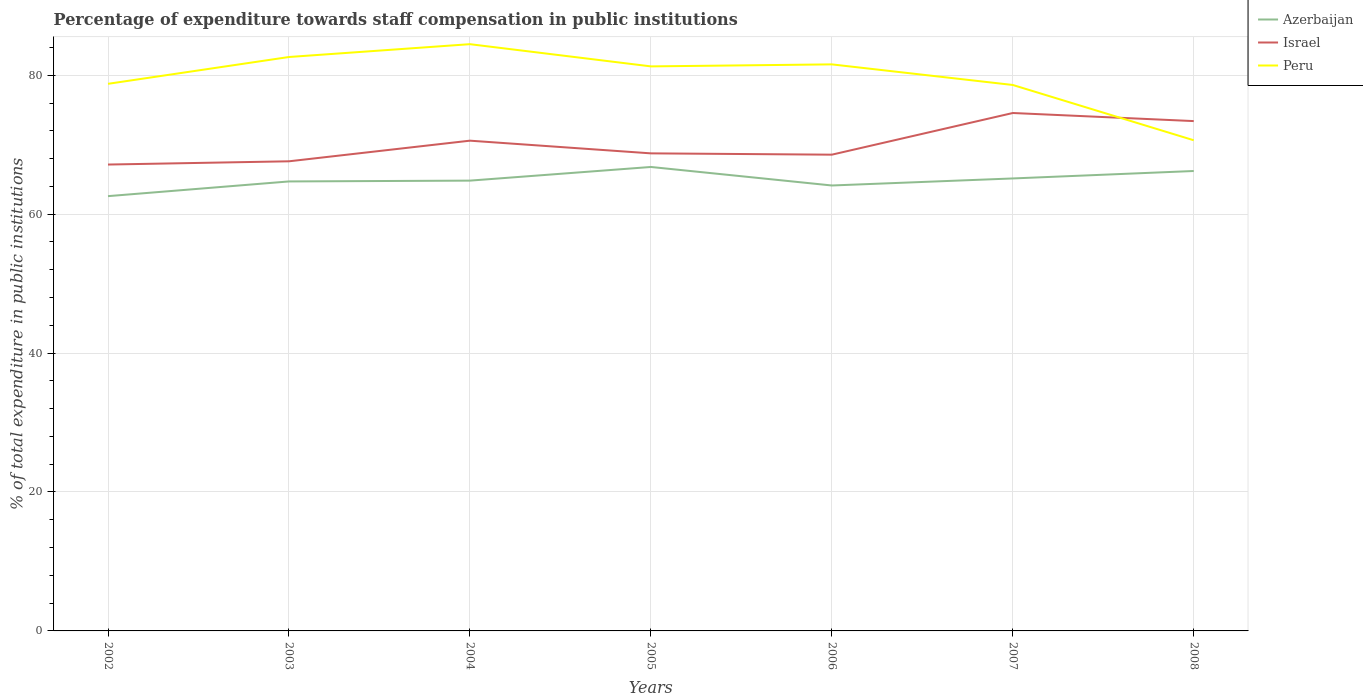How many different coloured lines are there?
Offer a terse response. 3. Is the number of lines equal to the number of legend labels?
Provide a short and direct response. Yes. Across all years, what is the maximum percentage of expenditure towards staff compensation in Peru?
Ensure brevity in your answer.  70.64. What is the total percentage of expenditure towards staff compensation in Israel in the graph?
Offer a very short reply. -3.44. What is the difference between the highest and the second highest percentage of expenditure towards staff compensation in Azerbaijan?
Your answer should be very brief. 4.2. What is the difference between the highest and the lowest percentage of expenditure towards staff compensation in Peru?
Your answer should be very brief. 4. Are the values on the major ticks of Y-axis written in scientific E-notation?
Give a very brief answer. No. Does the graph contain any zero values?
Your answer should be very brief. No. What is the title of the graph?
Provide a short and direct response. Percentage of expenditure towards staff compensation in public institutions. Does "Chad" appear as one of the legend labels in the graph?
Offer a very short reply. No. What is the label or title of the X-axis?
Your answer should be very brief. Years. What is the label or title of the Y-axis?
Ensure brevity in your answer.  % of total expenditure in public institutions. What is the % of total expenditure in public institutions in Azerbaijan in 2002?
Offer a terse response. 62.59. What is the % of total expenditure in public institutions of Israel in 2002?
Offer a very short reply. 67.14. What is the % of total expenditure in public institutions in Peru in 2002?
Your answer should be compact. 78.76. What is the % of total expenditure in public institutions in Azerbaijan in 2003?
Make the answer very short. 64.71. What is the % of total expenditure in public institutions in Israel in 2003?
Provide a short and direct response. 67.61. What is the % of total expenditure in public institutions in Peru in 2003?
Give a very brief answer. 82.62. What is the % of total expenditure in public institutions of Azerbaijan in 2004?
Give a very brief answer. 64.83. What is the % of total expenditure in public institutions of Israel in 2004?
Offer a very short reply. 70.58. What is the % of total expenditure in public institutions in Peru in 2004?
Ensure brevity in your answer.  84.47. What is the % of total expenditure in public institutions of Azerbaijan in 2005?
Give a very brief answer. 66.79. What is the % of total expenditure in public institutions of Israel in 2005?
Make the answer very short. 68.75. What is the % of total expenditure in public institutions in Peru in 2005?
Provide a succinct answer. 81.27. What is the % of total expenditure in public institutions in Azerbaijan in 2006?
Your response must be concise. 64.13. What is the % of total expenditure in public institutions in Israel in 2006?
Provide a short and direct response. 68.56. What is the % of total expenditure in public institutions in Peru in 2006?
Offer a very short reply. 81.56. What is the % of total expenditure in public institutions in Azerbaijan in 2007?
Your answer should be compact. 65.14. What is the % of total expenditure in public institutions of Israel in 2007?
Ensure brevity in your answer.  74.56. What is the % of total expenditure in public institutions of Peru in 2007?
Provide a short and direct response. 78.6. What is the % of total expenditure in public institutions in Azerbaijan in 2008?
Your answer should be very brief. 66.21. What is the % of total expenditure in public institutions of Israel in 2008?
Provide a short and direct response. 73.4. What is the % of total expenditure in public institutions of Peru in 2008?
Offer a terse response. 70.64. Across all years, what is the maximum % of total expenditure in public institutions of Azerbaijan?
Your response must be concise. 66.79. Across all years, what is the maximum % of total expenditure in public institutions in Israel?
Provide a short and direct response. 74.56. Across all years, what is the maximum % of total expenditure in public institutions of Peru?
Keep it short and to the point. 84.47. Across all years, what is the minimum % of total expenditure in public institutions in Azerbaijan?
Your answer should be compact. 62.59. Across all years, what is the minimum % of total expenditure in public institutions of Israel?
Provide a short and direct response. 67.14. Across all years, what is the minimum % of total expenditure in public institutions of Peru?
Provide a short and direct response. 70.64. What is the total % of total expenditure in public institutions in Azerbaijan in the graph?
Your answer should be very brief. 454.39. What is the total % of total expenditure in public institutions of Israel in the graph?
Your response must be concise. 490.59. What is the total % of total expenditure in public institutions of Peru in the graph?
Give a very brief answer. 557.92. What is the difference between the % of total expenditure in public institutions in Azerbaijan in 2002 and that in 2003?
Your answer should be very brief. -2.12. What is the difference between the % of total expenditure in public institutions of Israel in 2002 and that in 2003?
Give a very brief answer. -0.47. What is the difference between the % of total expenditure in public institutions of Peru in 2002 and that in 2003?
Give a very brief answer. -3.86. What is the difference between the % of total expenditure in public institutions of Azerbaijan in 2002 and that in 2004?
Give a very brief answer. -2.23. What is the difference between the % of total expenditure in public institutions of Israel in 2002 and that in 2004?
Make the answer very short. -3.44. What is the difference between the % of total expenditure in public institutions of Peru in 2002 and that in 2004?
Make the answer very short. -5.71. What is the difference between the % of total expenditure in public institutions of Azerbaijan in 2002 and that in 2005?
Your response must be concise. -4.2. What is the difference between the % of total expenditure in public institutions of Israel in 2002 and that in 2005?
Keep it short and to the point. -1.61. What is the difference between the % of total expenditure in public institutions of Peru in 2002 and that in 2005?
Offer a very short reply. -2.51. What is the difference between the % of total expenditure in public institutions of Azerbaijan in 2002 and that in 2006?
Provide a succinct answer. -1.53. What is the difference between the % of total expenditure in public institutions in Israel in 2002 and that in 2006?
Make the answer very short. -1.42. What is the difference between the % of total expenditure in public institutions of Peru in 2002 and that in 2006?
Provide a short and direct response. -2.8. What is the difference between the % of total expenditure in public institutions of Azerbaijan in 2002 and that in 2007?
Provide a short and direct response. -2.55. What is the difference between the % of total expenditure in public institutions of Israel in 2002 and that in 2007?
Your response must be concise. -7.42. What is the difference between the % of total expenditure in public institutions in Peru in 2002 and that in 2007?
Your response must be concise. 0.17. What is the difference between the % of total expenditure in public institutions of Azerbaijan in 2002 and that in 2008?
Make the answer very short. -3.62. What is the difference between the % of total expenditure in public institutions in Israel in 2002 and that in 2008?
Your answer should be compact. -6.26. What is the difference between the % of total expenditure in public institutions in Peru in 2002 and that in 2008?
Your response must be concise. 8.13. What is the difference between the % of total expenditure in public institutions of Azerbaijan in 2003 and that in 2004?
Keep it short and to the point. -0.12. What is the difference between the % of total expenditure in public institutions of Israel in 2003 and that in 2004?
Provide a succinct answer. -2.97. What is the difference between the % of total expenditure in public institutions in Peru in 2003 and that in 2004?
Your answer should be compact. -1.85. What is the difference between the % of total expenditure in public institutions of Azerbaijan in 2003 and that in 2005?
Keep it short and to the point. -2.08. What is the difference between the % of total expenditure in public institutions in Israel in 2003 and that in 2005?
Give a very brief answer. -1.14. What is the difference between the % of total expenditure in public institutions in Peru in 2003 and that in 2005?
Provide a succinct answer. 1.35. What is the difference between the % of total expenditure in public institutions in Azerbaijan in 2003 and that in 2006?
Provide a succinct answer. 0.58. What is the difference between the % of total expenditure in public institutions in Israel in 2003 and that in 2006?
Offer a terse response. -0.95. What is the difference between the % of total expenditure in public institutions in Peru in 2003 and that in 2006?
Your response must be concise. 1.06. What is the difference between the % of total expenditure in public institutions in Azerbaijan in 2003 and that in 2007?
Offer a very short reply. -0.43. What is the difference between the % of total expenditure in public institutions in Israel in 2003 and that in 2007?
Offer a very short reply. -6.95. What is the difference between the % of total expenditure in public institutions of Peru in 2003 and that in 2007?
Provide a succinct answer. 4.03. What is the difference between the % of total expenditure in public institutions in Azerbaijan in 2003 and that in 2008?
Your answer should be compact. -1.5. What is the difference between the % of total expenditure in public institutions in Israel in 2003 and that in 2008?
Your response must be concise. -5.79. What is the difference between the % of total expenditure in public institutions of Peru in 2003 and that in 2008?
Give a very brief answer. 11.99. What is the difference between the % of total expenditure in public institutions in Azerbaijan in 2004 and that in 2005?
Offer a very short reply. -1.97. What is the difference between the % of total expenditure in public institutions in Israel in 2004 and that in 2005?
Provide a short and direct response. 1.83. What is the difference between the % of total expenditure in public institutions in Peru in 2004 and that in 2005?
Keep it short and to the point. 3.2. What is the difference between the % of total expenditure in public institutions of Azerbaijan in 2004 and that in 2006?
Offer a terse response. 0.7. What is the difference between the % of total expenditure in public institutions of Israel in 2004 and that in 2006?
Ensure brevity in your answer.  2.02. What is the difference between the % of total expenditure in public institutions of Peru in 2004 and that in 2006?
Provide a short and direct response. 2.91. What is the difference between the % of total expenditure in public institutions of Azerbaijan in 2004 and that in 2007?
Your answer should be compact. -0.31. What is the difference between the % of total expenditure in public institutions in Israel in 2004 and that in 2007?
Ensure brevity in your answer.  -3.98. What is the difference between the % of total expenditure in public institutions in Peru in 2004 and that in 2007?
Give a very brief answer. 5.87. What is the difference between the % of total expenditure in public institutions in Azerbaijan in 2004 and that in 2008?
Ensure brevity in your answer.  -1.39. What is the difference between the % of total expenditure in public institutions of Israel in 2004 and that in 2008?
Make the answer very short. -2.82. What is the difference between the % of total expenditure in public institutions of Peru in 2004 and that in 2008?
Provide a succinct answer. 13.83. What is the difference between the % of total expenditure in public institutions in Azerbaijan in 2005 and that in 2006?
Provide a short and direct response. 2.67. What is the difference between the % of total expenditure in public institutions of Israel in 2005 and that in 2006?
Your response must be concise. 0.19. What is the difference between the % of total expenditure in public institutions of Peru in 2005 and that in 2006?
Keep it short and to the point. -0.29. What is the difference between the % of total expenditure in public institutions of Azerbaijan in 2005 and that in 2007?
Offer a terse response. 1.65. What is the difference between the % of total expenditure in public institutions of Israel in 2005 and that in 2007?
Offer a very short reply. -5.81. What is the difference between the % of total expenditure in public institutions in Peru in 2005 and that in 2007?
Offer a very short reply. 2.68. What is the difference between the % of total expenditure in public institutions of Azerbaijan in 2005 and that in 2008?
Ensure brevity in your answer.  0.58. What is the difference between the % of total expenditure in public institutions of Israel in 2005 and that in 2008?
Offer a very short reply. -4.65. What is the difference between the % of total expenditure in public institutions in Peru in 2005 and that in 2008?
Provide a succinct answer. 10.64. What is the difference between the % of total expenditure in public institutions of Azerbaijan in 2006 and that in 2007?
Offer a very short reply. -1.01. What is the difference between the % of total expenditure in public institutions of Israel in 2006 and that in 2007?
Your answer should be compact. -6. What is the difference between the % of total expenditure in public institutions of Peru in 2006 and that in 2007?
Offer a very short reply. 2.97. What is the difference between the % of total expenditure in public institutions of Azerbaijan in 2006 and that in 2008?
Provide a succinct answer. -2.09. What is the difference between the % of total expenditure in public institutions in Israel in 2006 and that in 2008?
Provide a succinct answer. -4.83. What is the difference between the % of total expenditure in public institutions of Peru in 2006 and that in 2008?
Offer a terse response. 10.92. What is the difference between the % of total expenditure in public institutions in Azerbaijan in 2007 and that in 2008?
Offer a very short reply. -1.07. What is the difference between the % of total expenditure in public institutions in Israel in 2007 and that in 2008?
Keep it short and to the point. 1.16. What is the difference between the % of total expenditure in public institutions of Peru in 2007 and that in 2008?
Provide a succinct answer. 7.96. What is the difference between the % of total expenditure in public institutions in Azerbaijan in 2002 and the % of total expenditure in public institutions in Israel in 2003?
Provide a succinct answer. -5.01. What is the difference between the % of total expenditure in public institutions in Azerbaijan in 2002 and the % of total expenditure in public institutions in Peru in 2003?
Give a very brief answer. -20.03. What is the difference between the % of total expenditure in public institutions of Israel in 2002 and the % of total expenditure in public institutions of Peru in 2003?
Provide a succinct answer. -15.48. What is the difference between the % of total expenditure in public institutions of Azerbaijan in 2002 and the % of total expenditure in public institutions of Israel in 2004?
Offer a terse response. -7.99. What is the difference between the % of total expenditure in public institutions in Azerbaijan in 2002 and the % of total expenditure in public institutions in Peru in 2004?
Ensure brevity in your answer.  -21.88. What is the difference between the % of total expenditure in public institutions of Israel in 2002 and the % of total expenditure in public institutions of Peru in 2004?
Your response must be concise. -17.33. What is the difference between the % of total expenditure in public institutions of Azerbaijan in 2002 and the % of total expenditure in public institutions of Israel in 2005?
Offer a very short reply. -6.16. What is the difference between the % of total expenditure in public institutions in Azerbaijan in 2002 and the % of total expenditure in public institutions in Peru in 2005?
Provide a short and direct response. -18.68. What is the difference between the % of total expenditure in public institutions in Israel in 2002 and the % of total expenditure in public institutions in Peru in 2005?
Keep it short and to the point. -14.13. What is the difference between the % of total expenditure in public institutions in Azerbaijan in 2002 and the % of total expenditure in public institutions in Israel in 2006?
Ensure brevity in your answer.  -5.97. What is the difference between the % of total expenditure in public institutions in Azerbaijan in 2002 and the % of total expenditure in public institutions in Peru in 2006?
Provide a short and direct response. -18.97. What is the difference between the % of total expenditure in public institutions of Israel in 2002 and the % of total expenditure in public institutions of Peru in 2006?
Keep it short and to the point. -14.42. What is the difference between the % of total expenditure in public institutions of Azerbaijan in 2002 and the % of total expenditure in public institutions of Israel in 2007?
Provide a succinct answer. -11.97. What is the difference between the % of total expenditure in public institutions of Azerbaijan in 2002 and the % of total expenditure in public institutions of Peru in 2007?
Your answer should be very brief. -16. What is the difference between the % of total expenditure in public institutions in Israel in 2002 and the % of total expenditure in public institutions in Peru in 2007?
Make the answer very short. -11.46. What is the difference between the % of total expenditure in public institutions in Azerbaijan in 2002 and the % of total expenditure in public institutions in Israel in 2008?
Give a very brief answer. -10.8. What is the difference between the % of total expenditure in public institutions in Azerbaijan in 2002 and the % of total expenditure in public institutions in Peru in 2008?
Your response must be concise. -8.04. What is the difference between the % of total expenditure in public institutions in Israel in 2002 and the % of total expenditure in public institutions in Peru in 2008?
Ensure brevity in your answer.  -3.5. What is the difference between the % of total expenditure in public institutions in Azerbaijan in 2003 and the % of total expenditure in public institutions in Israel in 2004?
Offer a terse response. -5.87. What is the difference between the % of total expenditure in public institutions of Azerbaijan in 2003 and the % of total expenditure in public institutions of Peru in 2004?
Provide a short and direct response. -19.76. What is the difference between the % of total expenditure in public institutions of Israel in 2003 and the % of total expenditure in public institutions of Peru in 2004?
Your answer should be very brief. -16.86. What is the difference between the % of total expenditure in public institutions of Azerbaijan in 2003 and the % of total expenditure in public institutions of Israel in 2005?
Offer a terse response. -4.04. What is the difference between the % of total expenditure in public institutions of Azerbaijan in 2003 and the % of total expenditure in public institutions of Peru in 2005?
Give a very brief answer. -16.56. What is the difference between the % of total expenditure in public institutions of Israel in 2003 and the % of total expenditure in public institutions of Peru in 2005?
Provide a short and direct response. -13.66. What is the difference between the % of total expenditure in public institutions of Azerbaijan in 2003 and the % of total expenditure in public institutions of Israel in 2006?
Your response must be concise. -3.85. What is the difference between the % of total expenditure in public institutions in Azerbaijan in 2003 and the % of total expenditure in public institutions in Peru in 2006?
Make the answer very short. -16.85. What is the difference between the % of total expenditure in public institutions of Israel in 2003 and the % of total expenditure in public institutions of Peru in 2006?
Offer a terse response. -13.95. What is the difference between the % of total expenditure in public institutions in Azerbaijan in 2003 and the % of total expenditure in public institutions in Israel in 2007?
Your answer should be very brief. -9.85. What is the difference between the % of total expenditure in public institutions in Azerbaijan in 2003 and the % of total expenditure in public institutions in Peru in 2007?
Your answer should be very brief. -13.89. What is the difference between the % of total expenditure in public institutions in Israel in 2003 and the % of total expenditure in public institutions in Peru in 2007?
Offer a very short reply. -10.99. What is the difference between the % of total expenditure in public institutions of Azerbaijan in 2003 and the % of total expenditure in public institutions of Israel in 2008?
Your answer should be compact. -8.69. What is the difference between the % of total expenditure in public institutions in Azerbaijan in 2003 and the % of total expenditure in public institutions in Peru in 2008?
Your response must be concise. -5.93. What is the difference between the % of total expenditure in public institutions in Israel in 2003 and the % of total expenditure in public institutions in Peru in 2008?
Make the answer very short. -3.03. What is the difference between the % of total expenditure in public institutions in Azerbaijan in 2004 and the % of total expenditure in public institutions in Israel in 2005?
Keep it short and to the point. -3.93. What is the difference between the % of total expenditure in public institutions in Azerbaijan in 2004 and the % of total expenditure in public institutions in Peru in 2005?
Keep it short and to the point. -16.45. What is the difference between the % of total expenditure in public institutions in Israel in 2004 and the % of total expenditure in public institutions in Peru in 2005?
Keep it short and to the point. -10.69. What is the difference between the % of total expenditure in public institutions of Azerbaijan in 2004 and the % of total expenditure in public institutions of Israel in 2006?
Provide a succinct answer. -3.74. What is the difference between the % of total expenditure in public institutions in Azerbaijan in 2004 and the % of total expenditure in public institutions in Peru in 2006?
Your answer should be very brief. -16.74. What is the difference between the % of total expenditure in public institutions in Israel in 2004 and the % of total expenditure in public institutions in Peru in 2006?
Your response must be concise. -10.98. What is the difference between the % of total expenditure in public institutions of Azerbaijan in 2004 and the % of total expenditure in public institutions of Israel in 2007?
Offer a very short reply. -9.74. What is the difference between the % of total expenditure in public institutions of Azerbaijan in 2004 and the % of total expenditure in public institutions of Peru in 2007?
Make the answer very short. -13.77. What is the difference between the % of total expenditure in public institutions of Israel in 2004 and the % of total expenditure in public institutions of Peru in 2007?
Your answer should be very brief. -8.02. What is the difference between the % of total expenditure in public institutions in Azerbaijan in 2004 and the % of total expenditure in public institutions in Israel in 2008?
Offer a very short reply. -8.57. What is the difference between the % of total expenditure in public institutions in Azerbaijan in 2004 and the % of total expenditure in public institutions in Peru in 2008?
Offer a very short reply. -5.81. What is the difference between the % of total expenditure in public institutions of Israel in 2004 and the % of total expenditure in public institutions of Peru in 2008?
Your response must be concise. -0.06. What is the difference between the % of total expenditure in public institutions of Azerbaijan in 2005 and the % of total expenditure in public institutions of Israel in 2006?
Provide a short and direct response. -1.77. What is the difference between the % of total expenditure in public institutions of Azerbaijan in 2005 and the % of total expenditure in public institutions of Peru in 2006?
Your response must be concise. -14.77. What is the difference between the % of total expenditure in public institutions in Israel in 2005 and the % of total expenditure in public institutions in Peru in 2006?
Make the answer very short. -12.81. What is the difference between the % of total expenditure in public institutions of Azerbaijan in 2005 and the % of total expenditure in public institutions of Israel in 2007?
Make the answer very short. -7.77. What is the difference between the % of total expenditure in public institutions in Azerbaijan in 2005 and the % of total expenditure in public institutions in Peru in 2007?
Offer a very short reply. -11.8. What is the difference between the % of total expenditure in public institutions of Israel in 2005 and the % of total expenditure in public institutions of Peru in 2007?
Keep it short and to the point. -9.84. What is the difference between the % of total expenditure in public institutions in Azerbaijan in 2005 and the % of total expenditure in public institutions in Israel in 2008?
Keep it short and to the point. -6.6. What is the difference between the % of total expenditure in public institutions in Azerbaijan in 2005 and the % of total expenditure in public institutions in Peru in 2008?
Give a very brief answer. -3.84. What is the difference between the % of total expenditure in public institutions of Israel in 2005 and the % of total expenditure in public institutions of Peru in 2008?
Offer a terse response. -1.89. What is the difference between the % of total expenditure in public institutions in Azerbaijan in 2006 and the % of total expenditure in public institutions in Israel in 2007?
Provide a short and direct response. -10.43. What is the difference between the % of total expenditure in public institutions in Azerbaijan in 2006 and the % of total expenditure in public institutions in Peru in 2007?
Provide a short and direct response. -14.47. What is the difference between the % of total expenditure in public institutions in Israel in 2006 and the % of total expenditure in public institutions in Peru in 2007?
Your response must be concise. -10.03. What is the difference between the % of total expenditure in public institutions in Azerbaijan in 2006 and the % of total expenditure in public institutions in Israel in 2008?
Provide a succinct answer. -9.27. What is the difference between the % of total expenditure in public institutions in Azerbaijan in 2006 and the % of total expenditure in public institutions in Peru in 2008?
Your response must be concise. -6.51. What is the difference between the % of total expenditure in public institutions of Israel in 2006 and the % of total expenditure in public institutions of Peru in 2008?
Give a very brief answer. -2.07. What is the difference between the % of total expenditure in public institutions in Azerbaijan in 2007 and the % of total expenditure in public institutions in Israel in 2008?
Make the answer very short. -8.26. What is the difference between the % of total expenditure in public institutions of Azerbaijan in 2007 and the % of total expenditure in public institutions of Peru in 2008?
Provide a short and direct response. -5.5. What is the difference between the % of total expenditure in public institutions in Israel in 2007 and the % of total expenditure in public institutions in Peru in 2008?
Keep it short and to the point. 3.92. What is the average % of total expenditure in public institutions in Azerbaijan per year?
Provide a succinct answer. 64.91. What is the average % of total expenditure in public institutions of Israel per year?
Your answer should be compact. 70.08. What is the average % of total expenditure in public institutions of Peru per year?
Your response must be concise. 79.7. In the year 2002, what is the difference between the % of total expenditure in public institutions of Azerbaijan and % of total expenditure in public institutions of Israel?
Your response must be concise. -4.55. In the year 2002, what is the difference between the % of total expenditure in public institutions in Azerbaijan and % of total expenditure in public institutions in Peru?
Your answer should be compact. -16.17. In the year 2002, what is the difference between the % of total expenditure in public institutions in Israel and % of total expenditure in public institutions in Peru?
Your response must be concise. -11.62. In the year 2003, what is the difference between the % of total expenditure in public institutions of Azerbaijan and % of total expenditure in public institutions of Israel?
Offer a very short reply. -2.9. In the year 2003, what is the difference between the % of total expenditure in public institutions of Azerbaijan and % of total expenditure in public institutions of Peru?
Make the answer very short. -17.91. In the year 2003, what is the difference between the % of total expenditure in public institutions in Israel and % of total expenditure in public institutions in Peru?
Your answer should be compact. -15.02. In the year 2004, what is the difference between the % of total expenditure in public institutions of Azerbaijan and % of total expenditure in public institutions of Israel?
Make the answer very short. -5.75. In the year 2004, what is the difference between the % of total expenditure in public institutions of Azerbaijan and % of total expenditure in public institutions of Peru?
Provide a succinct answer. -19.64. In the year 2004, what is the difference between the % of total expenditure in public institutions in Israel and % of total expenditure in public institutions in Peru?
Offer a very short reply. -13.89. In the year 2005, what is the difference between the % of total expenditure in public institutions of Azerbaijan and % of total expenditure in public institutions of Israel?
Provide a succinct answer. -1.96. In the year 2005, what is the difference between the % of total expenditure in public institutions in Azerbaijan and % of total expenditure in public institutions in Peru?
Make the answer very short. -14.48. In the year 2005, what is the difference between the % of total expenditure in public institutions of Israel and % of total expenditure in public institutions of Peru?
Provide a short and direct response. -12.52. In the year 2006, what is the difference between the % of total expenditure in public institutions in Azerbaijan and % of total expenditure in public institutions in Israel?
Ensure brevity in your answer.  -4.44. In the year 2006, what is the difference between the % of total expenditure in public institutions of Azerbaijan and % of total expenditure in public institutions of Peru?
Offer a terse response. -17.43. In the year 2006, what is the difference between the % of total expenditure in public institutions of Israel and % of total expenditure in public institutions of Peru?
Your answer should be very brief. -13. In the year 2007, what is the difference between the % of total expenditure in public institutions in Azerbaijan and % of total expenditure in public institutions in Israel?
Your response must be concise. -9.42. In the year 2007, what is the difference between the % of total expenditure in public institutions in Azerbaijan and % of total expenditure in public institutions in Peru?
Your answer should be very brief. -13.46. In the year 2007, what is the difference between the % of total expenditure in public institutions in Israel and % of total expenditure in public institutions in Peru?
Offer a terse response. -4.03. In the year 2008, what is the difference between the % of total expenditure in public institutions in Azerbaijan and % of total expenditure in public institutions in Israel?
Your answer should be compact. -7.18. In the year 2008, what is the difference between the % of total expenditure in public institutions of Azerbaijan and % of total expenditure in public institutions of Peru?
Ensure brevity in your answer.  -4.42. In the year 2008, what is the difference between the % of total expenditure in public institutions of Israel and % of total expenditure in public institutions of Peru?
Offer a terse response. 2.76. What is the ratio of the % of total expenditure in public institutions in Azerbaijan in 2002 to that in 2003?
Offer a terse response. 0.97. What is the ratio of the % of total expenditure in public institutions in Israel in 2002 to that in 2003?
Your answer should be very brief. 0.99. What is the ratio of the % of total expenditure in public institutions in Peru in 2002 to that in 2003?
Your response must be concise. 0.95. What is the ratio of the % of total expenditure in public institutions in Azerbaijan in 2002 to that in 2004?
Your answer should be very brief. 0.97. What is the ratio of the % of total expenditure in public institutions of Israel in 2002 to that in 2004?
Keep it short and to the point. 0.95. What is the ratio of the % of total expenditure in public institutions in Peru in 2002 to that in 2004?
Ensure brevity in your answer.  0.93. What is the ratio of the % of total expenditure in public institutions of Azerbaijan in 2002 to that in 2005?
Provide a succinct answer. 0.94. What is the ratio of the % of total expenditure in public institutions of Israel in 2002 to that in 2005?
Make the answer very short. 0.98. What is the ratio of the % of total expenditure in public institutions in Peru in 2002 to that in 2005?
Provide a succinct answer. 0.97. What is the ratio of the % of total expenditure in public institutions of Azerbaijan in 2002 to that in 2006?
Provide a succinct answer. 0.98. What is the ratio of the % of total expenditure in public institutions in Israel in 2002 to that in 2006?
Offer a very short reply. 0.98. What is the ratio of the % of total expenditure in public institutions in Peru in 2002 to that in 2006?
Make the answer very short. 0.97. What is the ratio of the % of total expenditure in public institutions of Azerbaijan in 2002 to that in 2007?
Provide a short and direct response. 0.96. What is the ratio of the % of total expenditure in public institutions in Israel in 2002 to that in 2007?
Make the answer very short. 0.9. What is the ratio of the % of total expenditure in public institutions in Azerbaijan in 2002 to that in 2008?
Offer a terse response. 0.95. What is the ratio of the % of total expenditure in public institutions of Israel in 2002 to that in 2008?
Keep it short and to the point. 0.91. What is the ratio of the % of total expenditure in public institutions of Peru in 2002 to that in 2008?
Your answer should be compact. 1.11. What is the ratio of the % of total expenditure in public institutions in Azerbaijan in 2003 to that in 2004?
Your response must be concise. 1. What is the ratio of the % of total expenditure in public institutions in Israel in 2003 to that in 2004?
Ensure brevity in your answer.  0.96. What is the ratio of the % of total expenditure in public institutions of Peru in 2003 to that in 2004?
Offer a terse response. 0.98. What is the ratio of the % of total expenditure in public institutions of Azerbaijan in 2003 to that in 2005?
Your answer should be very brief. 0.97. What is the ratio of the % of total expenditure in public institutions of Israel in 2003 to that in 2005?
Your response must be concise. 0.98. What is the ratio of the % of total expenditure in public institutions in Peru in 2003 to that in 2005?
Provide a short and direct response. 1.02. What is the ratio of the % of total expenditure in public institutions in Azerbaijan in 2003 to that in 2006?
Your answer should be very brief. 1.01. What is the ratio of the % of total expenditure in public institutions of Israel in 2003 to that in 2006?
Ensure brevity in your answer.  0.99. What is the ratio of the % of total expenditure in public institutions in Peru in 2003 to that in 2006?
Keep it short and to the point. 1.01. What is the ratio of the % of total expenditure in public institutions in Israel in 2003 to that in 2007?
Your answer should be very brief. 0.91. What is the ratio of the % of total expenditure in public institutions in Peru in 2003 to that in 2007?
Provide a succinct answer. 1.05. What is the ratio of the % of total expenditure in public institutions in Azerbaijan in 2003 to that in 2008?
Offer a terse response. 0.98. What is the ratio of the % of total expenditure in public institutions in Israel in 2003 to that in 2008?
Ensure brevity in your answer.  0.92. What is the ratio of the % of total expenditure in public institutions of Peru in 2003 to that in 2008?
Your answer should be compact. 1.17. What is the ratio of the % of total expenditure in public institutions of Azerbaijan in 2004 to that in 2005?
Your answer should be very brief. 0.97. What is the ratio of the % of total expenditure in public institutions in Israel in 2004 to that in 2005?
Your response must be concise. 1.03. What is the ratio of the % of total expenditure in public institutions in Peru in 2004 to that in 2005?
Your response must be concise. 1.04. What is the ratio of the % of total expenditure in public institutions of Azerbaijan in 2004 to that in 2006?
Provide a short and direct response. 1.01. What is the ratio of the % of total expenditure in public institutions of Israel in 2004 to that in 2006?
Ensure brevity in your answer.  1.03. What is the ratio of the % of total expenditure in public institutions of Peru in 2004 to that in 2006?
Keep it short and to the point. 1.04. What is the ratio of the % of total expenditure in public institutions of Azerbaijan in 2004 to that in 2007?
Offer a very short reply. 1. What is the ratio of the % of total expenditure in public institutions of Israel in 2004 to that in 2007?
Your response must be concise. 0.95. What is the ratio of the % of total expenditure in public institutions of Peru in 2004 to that in 2007?
Provide a succinct answer. 1.07. What is the ratio of the % of total expenditure in public institutions in Azerbaijan in 2004 to that in 2008?
Offer a very short reply. 0.98. What is the ratio of the % of total expenditure in public institutions in Israel in 2004 to that in 2008?
Ensure brevity in your answer.  0.96. What is the ratio of the % of total expenditure in public institutions of Peru in 2004 to that in 2008?
Your answer should be compact. 1.2. What is the ratio of the % of total expenditure in public institutions in Azerbaijan in 2005 to that in 2006?
Your answer should be very brief. 1.04. What is the ratio of the % of total expenditure in public institutions of Peru in 2005 to that in 2006?
Offer a very short reply. 1. What is the ratio of the % of total expenditure in public institutions of Azerbaijan in 2005 to that in 2007?
Offer a very short reply. 1.03. What is the ratio of the % of total expenditure in public institutions in Israel in 2005 to that in 2007?
Your answer should be very brief. 0.92. What is the ratio of the % of total expenditure in public institutions in Peru in 2005 to that in 2007?
Give a very brief answer. 1.03. What is the ratio of the % of total expenditure in public institutions in Azerbaijan in 2005 to that in 2008?
Provide a short and direct response. 1.01. What is the ratio of the % of total expenditure in public institutions in Israel in 2005 to that in 2008?
Your answer should be very brief. 0.94. What is the ratio of the % of total expenditure in public institutions of Peru in 2005 to that in 2008?
Offer a very short reply. 1.15. What is the ratio of the % of total expenditure in public institutions in Azerbaijan in 2006 to that in 2007?
Your response must be concise. 0.98. What is the ratio of the % of total expenditure in public institutions of Israel in 2006 to that in 2007?
Your response must be concise. 0.92. What is the ratio of the % of total expenditure in public institutions of Peru in 2006 to that in 2007?
Your response must be concise. 1.04. What is the ratio of the % of total expenditure in public institutions of Azerbaijan in 2006 to that in 2008?
Keep it short and to the point. 0.97. What is the ratio of the % of total expenditure in public institutions of Israel in 2006 to that in 2008?
Offer a terse response. 0.93. What is the ratio of the % of total expenditure in public institutions in Peru in 2006 to that in 2008?
Provide a short and direct response. 1.15. What is the ratio of the % of total expenditure in public institutions of Azerbaijan in 2007 to that in 2008?
Give a very brief answer. 0.98. What is the ratio of the % of total expenditure in public institutions of Israel in 2007 to that in 2008?
Your answer should be very brief. 1.02. What is the ratio of the % of total expenditure in public institutions of Peru in 2007 to that in 2008?
Offer a very short reply. 1.11. What is the difference between the highest and the second highest % of total expenditure in public institutions of Azerbaijan?
Make the answer very short. 0.58. What is the difference between the highest and the second highest % of total expenditure in public institutions in Israel?
Make the answer very short. 1.16. What is the difference between the highest and the second highest % of total expenditure in public institutions in Peru?
Provide a succinct answer. 1.85. What is the difference between the highest and the lowest % of total expenditure in public institutions in Azerbaijan?
Provide a succinct answer. 4.2. What is the difference between the highest and the lowest % of total expenditure in public institutions of Israel?
Provide a short and direct response. 7.42. What is the difference between the highest and the lowest % of total expenditure in public institutions in Peru?
Keep it short and to the point. 13.83. 